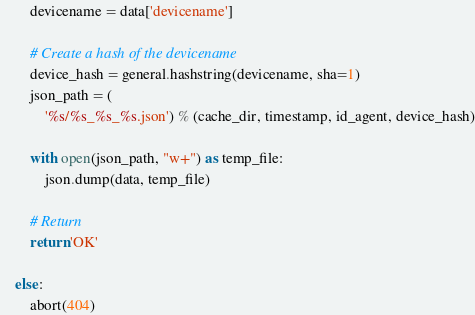<code> <loc_0><loc_0><loc_500><loc_500><_Python_>        devicename = data['devicename']

        # Create a hash of the devicename
        device_hash = general.hashstring(devicename, sha=1)
        json_path = (
            '%s/%s_%s_%s.json') % (cache_dir, timestamp, id_agent, device_hash)

        with open(json_path, "w+") as temp_file:
            json.dump(data, temp_file)

        # Return
        return 'OK'

    else:
        abort(404)
</code> 